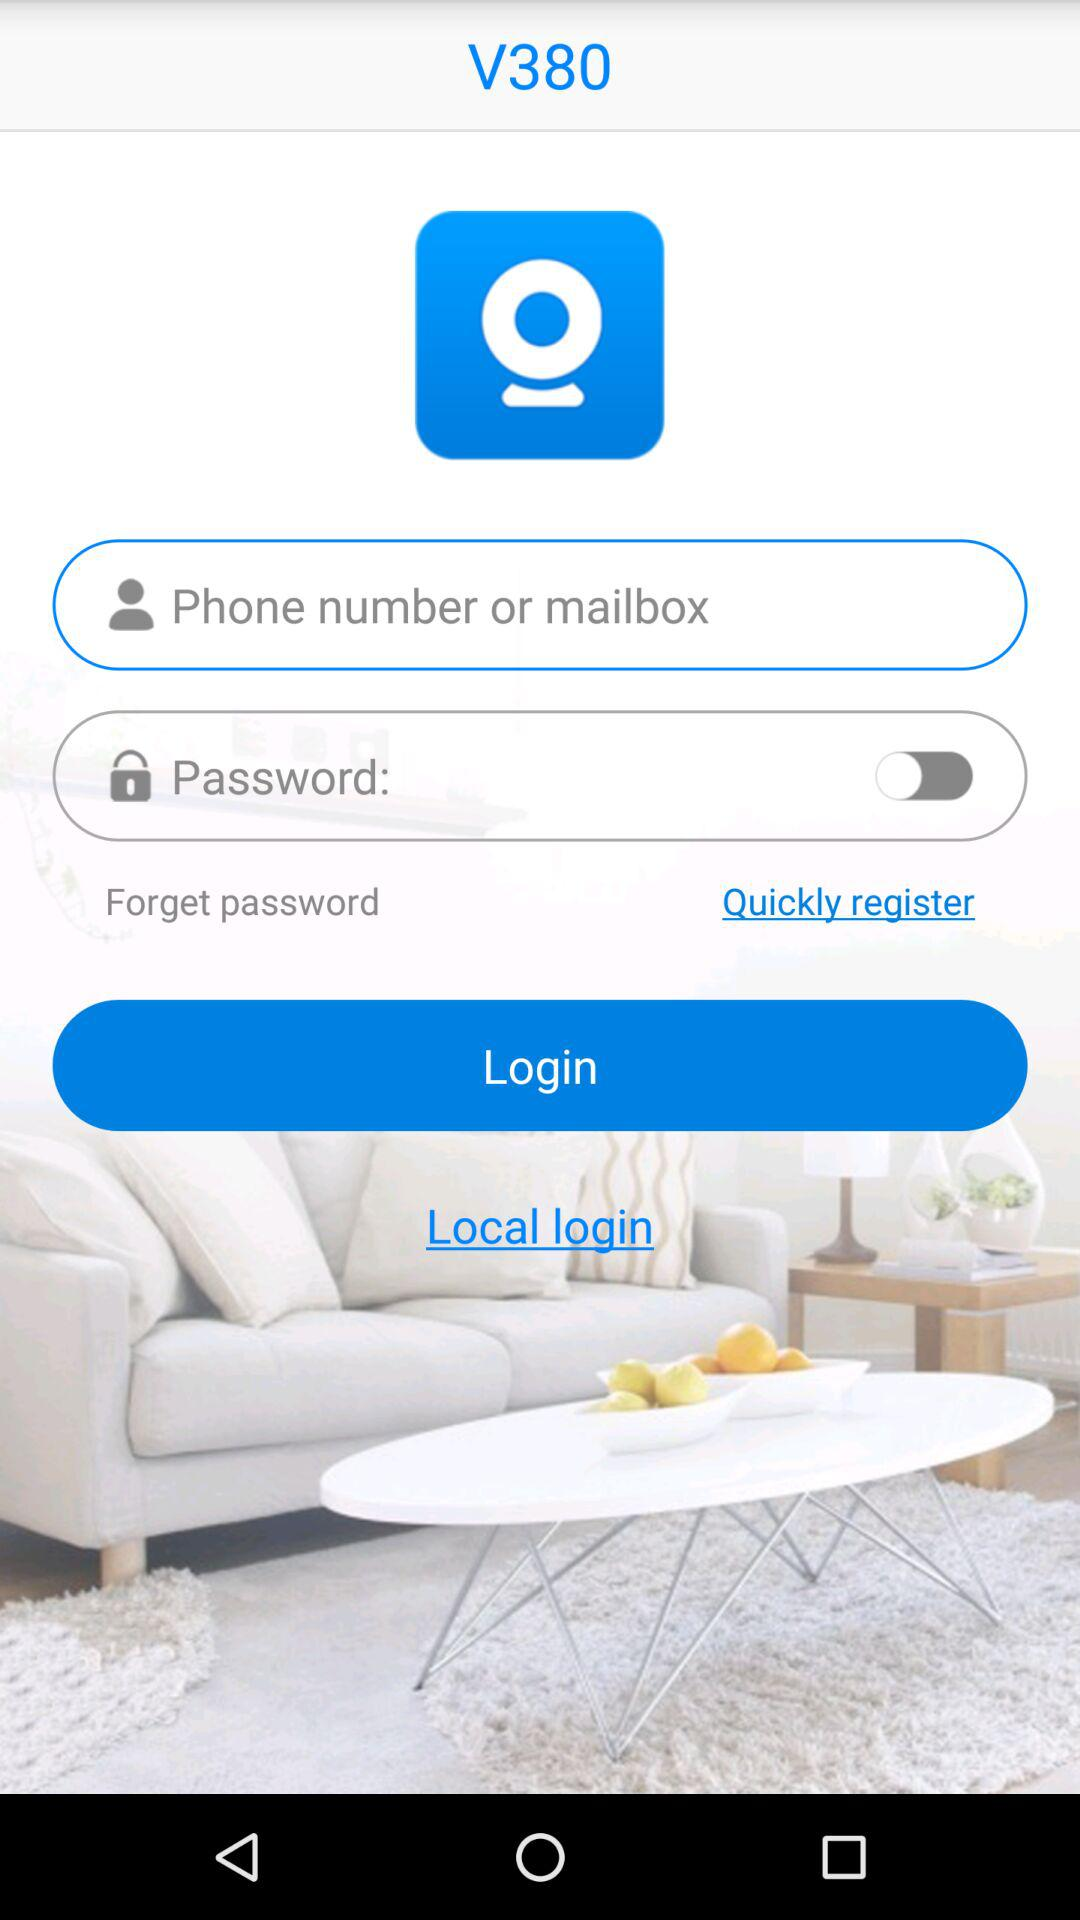What is the status of "Password"? The status is "off". 